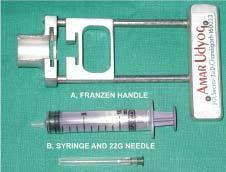s m phase required for transcutaneous fnac?
Answer the question using a single word or phrase. No 